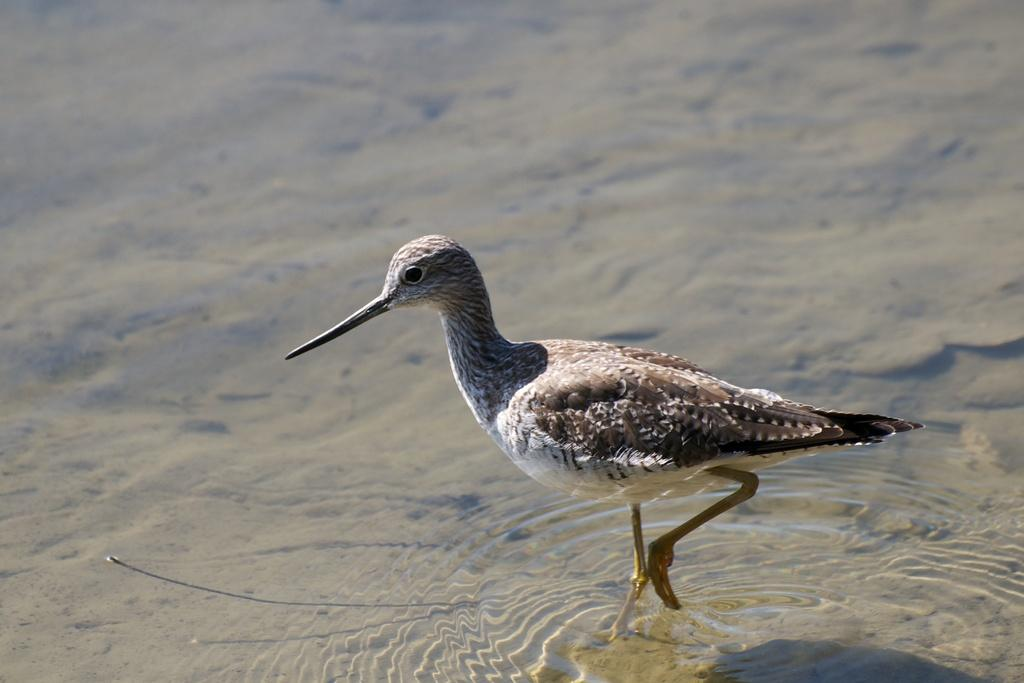What type of animal can be seen in the image? There is a bird in the image. Where is the bird located? The bird is on a water body. What type of branch is the bird holding in the image? There is no branch present in the image; the bird is on a water body. What color is the veil that the bird is wearing in the image? There is no veil present in the image; the bird is simply on a water body. 